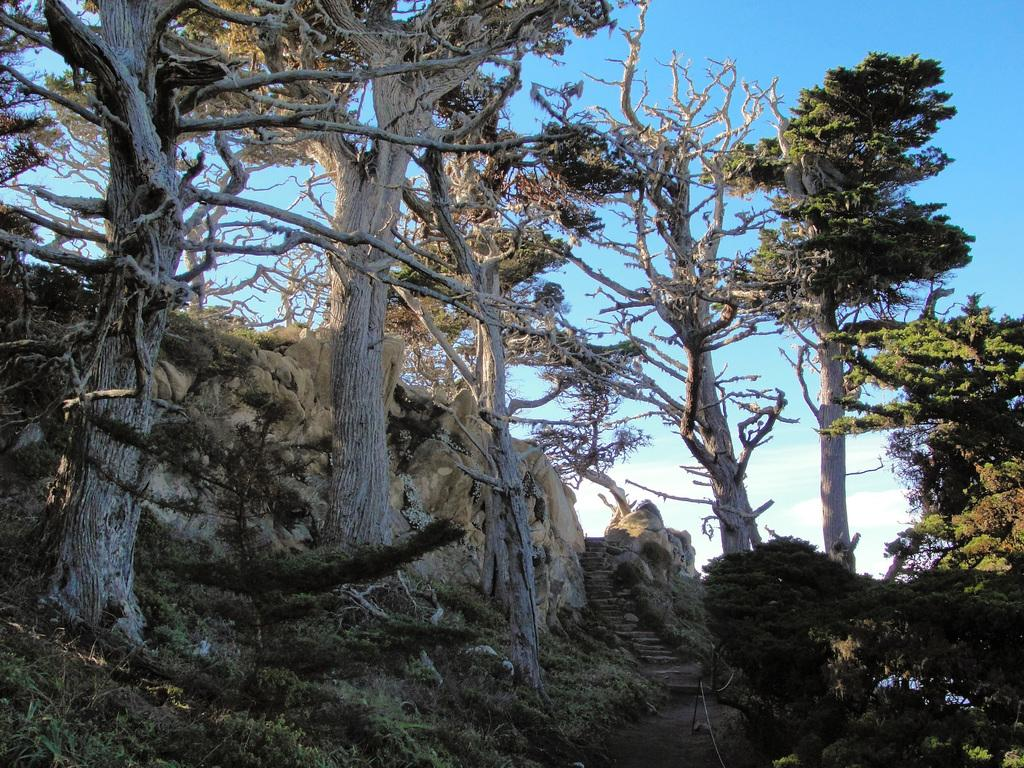What type of vegetation can be seen in the image? There are trees in the image. What is visible at the top of the image? The sky is visible at the top of the image. What type of ground cover is present at the bottom of the image? There is grass at the bottom of the image. Can you see a dog playing with a house in the image? There is no dog or house present in the image; it features trees, grass, and the sky. How many planes are flying in the image? There are no planes visible in the image. 